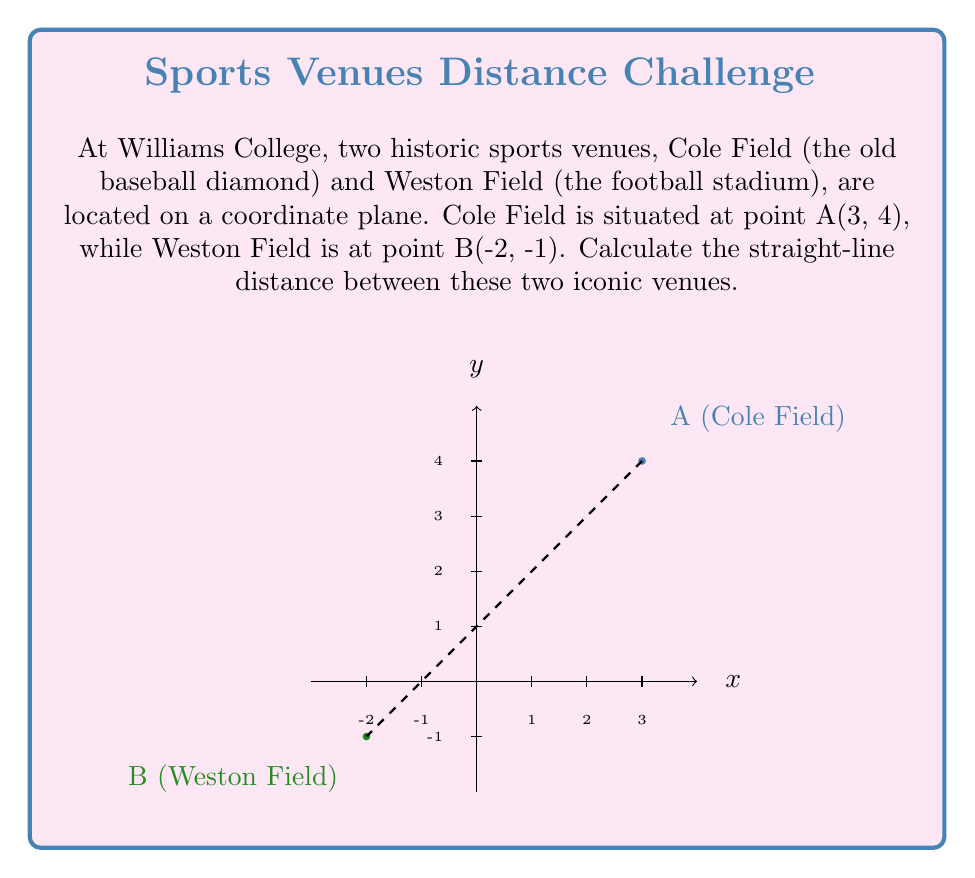Help me with this question. To calculate the distance between two points on a coordinate plane, we can use the distance formula, which is derived from the Pythagorean theorem:

$$d = \sqrt{(x_2 - x_1)^2 + (y_2 - y_1)^2}$$

Where $(x_1, y_1)$ are the coordinates of the first point and $(x_2, y_2)$ are the coordinates of the second point.

Let's plug in our values:
- Cole Field (A): $(x_1, y_1) = (3, 4)$
- Weston Field (B): $(x_2, y_2) = (-2, -1)$

Now, let's calculate step-by-step:

1) $d = \sqrt{(-2 - 3)^2 + (-1 - 4)^2}$

2) $d = \sqrt{(-5)^2 + (-5)^2}$

3) $d = \sqrt{25 + 25}$

4) $d = \sqrt{50}$

5) $d = 5\sqrt{2}$

Therefore, the straight-line distance between Cole Field and Weston Field is $5\sqrt{2}$ units.
Answer: $5\sqrt{2}$ units 